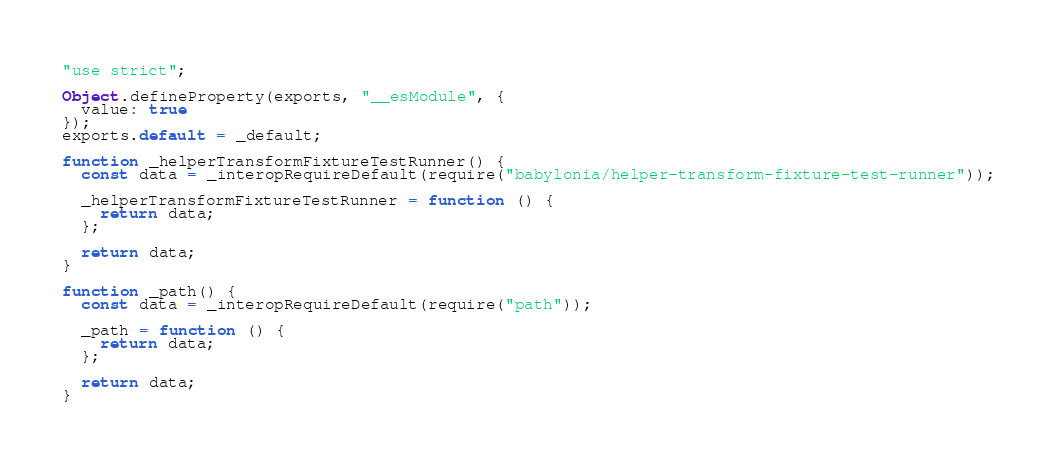Convert code to text. <code><loc_0><loc_0><loc_500><loc_500><_JavaScript_>"use strict";

Object.defineProperty(exports, "__esModule", {
  value: true
});
exports.default = _default;

function _helperTransformFixtureTestRunner() {
  const data = _interopRequireDefault(require("babylonia/helper-transform-fixture-test-runner"));

  _helperTransformFixtureTestRunner = function () {
    return data;
  };

  return data;
}

function _path() {
  const data = _interopRequireDefault(require("path"));

  _path = function () {
    return data;
  };

  return data;
}
</code> 